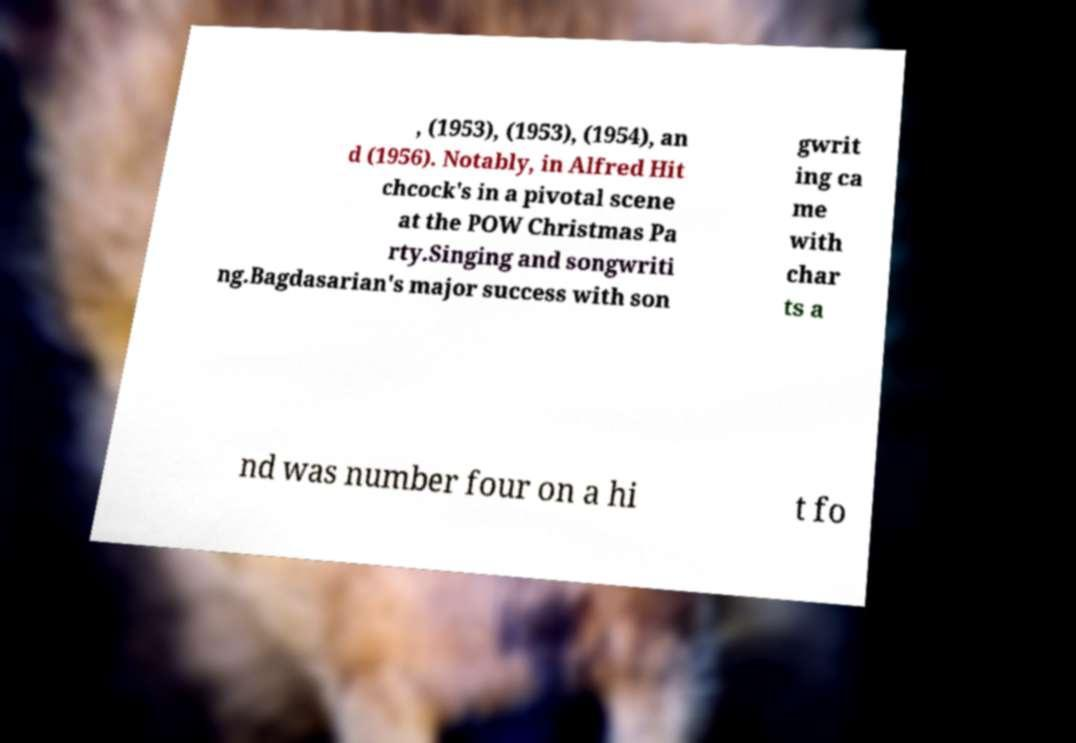I need the written content from this picture converted into text. Can you do that? , (1953), (1953), (1954), an d (1956). Notably, in Alfred Hit chcock's in a pivotal scene at the POW Christmas Pa rty.Singing and songwriti ng.Bagdasarian's major success with son gwrit ing ca me with char ts a nd was number four on a hi t fo 